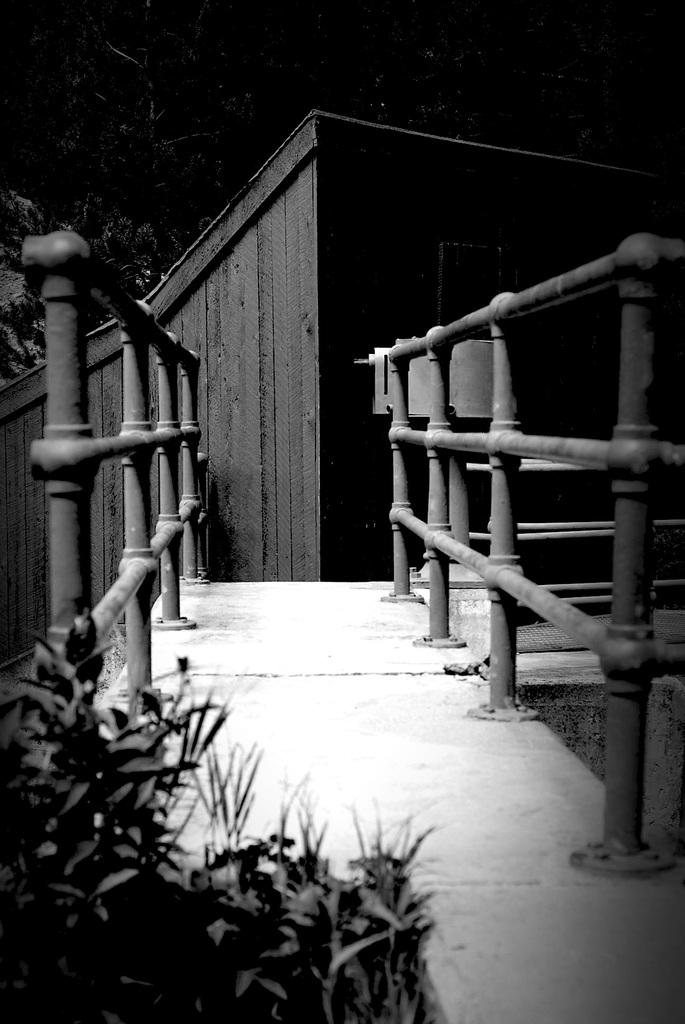What is the color scheme of the image? The image is black and white. What type of vegetation can be seen in the image? There are plants and trees in the image. What architectural feature is present in the image? There are railings and a house in the image. What is the pathway's location in the image? The pathway is in the middle of the railings. What type of wristwatch is the servant wearing in the image? There is no servant or wristwatch present in the image. How does the jelly interact with the plants in the image? There is no jelly present in the image; it is a black and white image featuring plants, railings, a house, and a pathway. 